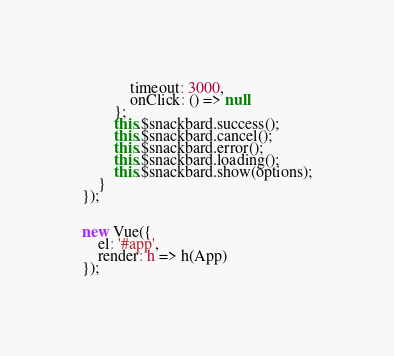<code> <loc_0><loc_0><loc_500><loc_500><_TypeScript_>            timeout: 3000,
            onClick: () => null
        };
        this.$snackbard.success();
        this.$snackbard.cancel();
        this.$snackbard.error();
        this.$snackbard.loading();
        this.$snackbard.show(options);
    }
});


new Vue({
    el: '#app',
    render: h => h(App)
});

</code> 